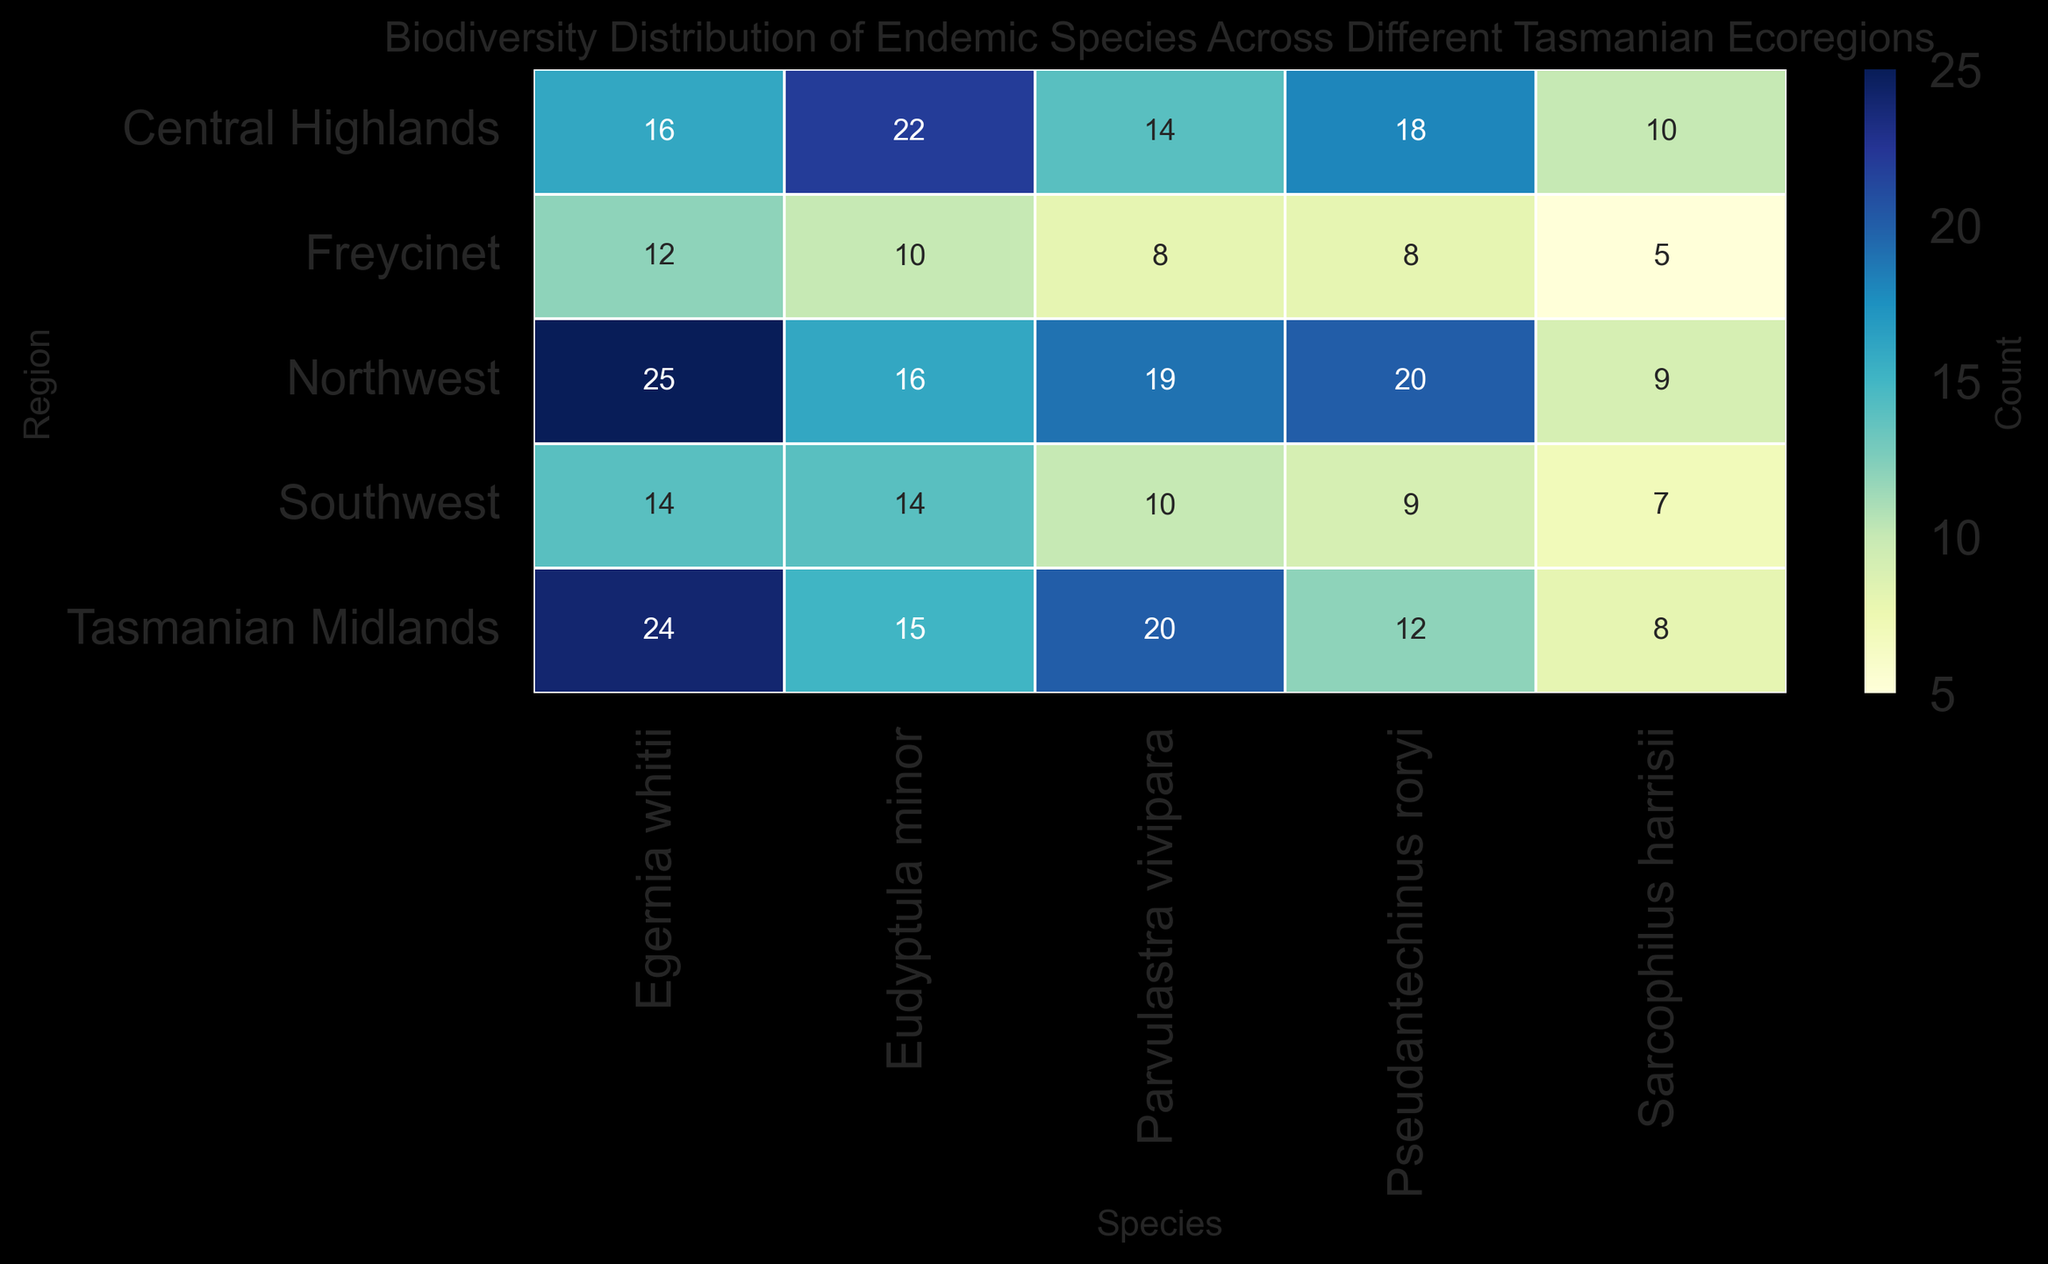Which region has the highest count of Eudyptula minor? By looking at the heatmap under the 'Eudyptula minor' column, the Central Highlands region has the highest value (22) compared to other regions.
Answer: Central Highlands Which species has the least count in Freycinet? Observing the counts in the Freycinet row, Sarcophilus harrisii has the lowest count (5) among the listed species.
Answer: Sarcophilus harrisii What is the total count of Pseudantechinus roryi in all regions combined? Summing up the counts of Pseudantechinus roryi across all regions: 12 (Tasmanian Midlands) + 18 (Central Highlands) + 8 (Freycinet) + 20 (Northwest) + 9 (Southwest) = 67.
Answer: 67 Does Egernia whitii have a higher count in the Tasmanian Midlands or the Northwest? Comparing the values for Egernia whitii in Tasmanian Midlands (24) and Northwest (25), the Northwest has a slightly higher count.
Answer: Northwest Which region has the most even distribution of counts across all species? Check the variation of counts within each row; the Southwest region shows relatively even counts (ranging from 7 to 14) for all species, compared to other regions where counts vary more widely.
Answer: Southwest What is the average count of Parvulastra vivipara across all regions? Adding up the counts of Parvulastra vivipara (20 + 14 + 8 + 19 + 10) and dividing by the number of regions (5) gives (71 / 5) = 14.2.
Answer: 14.2 Which species has the highest total count across all regions? Summing the counts of each species across all regions and then comparing: 
Eudyptula minor (15+22+10+16+14=77), 
Sarcophilus harrisii (8+10+5+9+7=39), 
Pseudantechinus roryi (12+18+8+20+9=67), 
Egernia whitii (24+16+12+25+14=91), 
Parvulastra vivipara (20+14+8+19+10=71).
Egernia whitii has the highest total count (91).
Answer: Egernia whitii Is there any region where the count of Sarcophilus harrisii is exactly half the count of Eudyptula minor? Checking the counts for each region:
Tasmanian Midlands: 8 (Sarcophilus harrisii) is not half of 15 (Eudyptula minor),
Central Highlands: 10 is not half of 22,
Freycinet: 5 is half of 10,
Northwest: 9 is not half of 16,
Southwest: 7 is not half of 14.
Freycinet meets the condition.
Answer: Freycinet What is the difference in the total counts of Eudyptula minor and Sarcophilus harrisii across all regions? Calculate the total for each species and then find the difference: 
Eudyptula minor (15+22+10+16+14=77) and 
Sarcophilus harrisii (8+10+5+9+7=39). 
The difference is 77 - 39 = 38.
Answer: 38 In which region does Pseudantechinus roryi outnumber Parvulastra vivipara by the largest margin? Calculate the differences for each region:
Tasmanian Midlands: 12 - 20 = -8,
Central Highlands: 18 - 14 = 4,
Freycinet: 8 - 8 = 0,
Northwest: 20 - 19 = 1,
Southwest: 9 - 10 = -1.
Central Highlands has the largest positive margin (4).
Answer: Central Highlands 